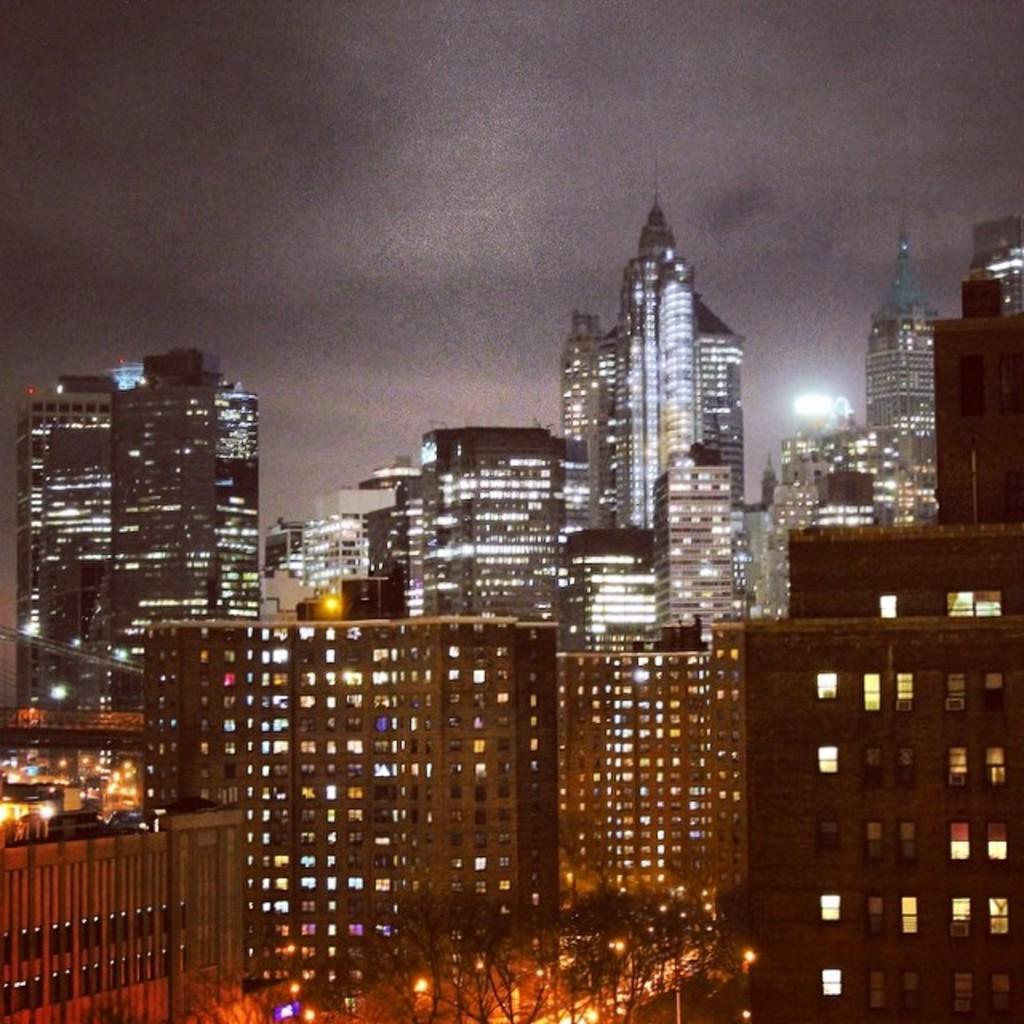Can you describe this image briefly? In this picture we can see few trees, buildings and lights. 